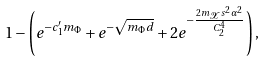Convert formula to latex. <formula><loc_0><loc_0><loc_500><loc_500>1 - \left ( e ^ { - c ^ { \prime } _ { 1 } m _ { \Phi } } + e ^ { - \sqrt { m _ { \Phi } d } } + 2 e ^ { - \frac { 2 m _ { \mathcal { X } } s ^ { 2 } \alpha ^ { 2 } } { C _ { 2 } ^ { 4 } } } \right ) ,</formula> 